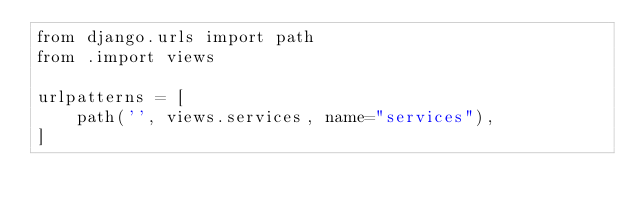Convert code to text. <code><loc_0><loc_0><loc_500><loc_500><_Python_>from django.urls import path
from .import views

urlpatterns = [
    path('', views.services, name="services"),
]</code> 